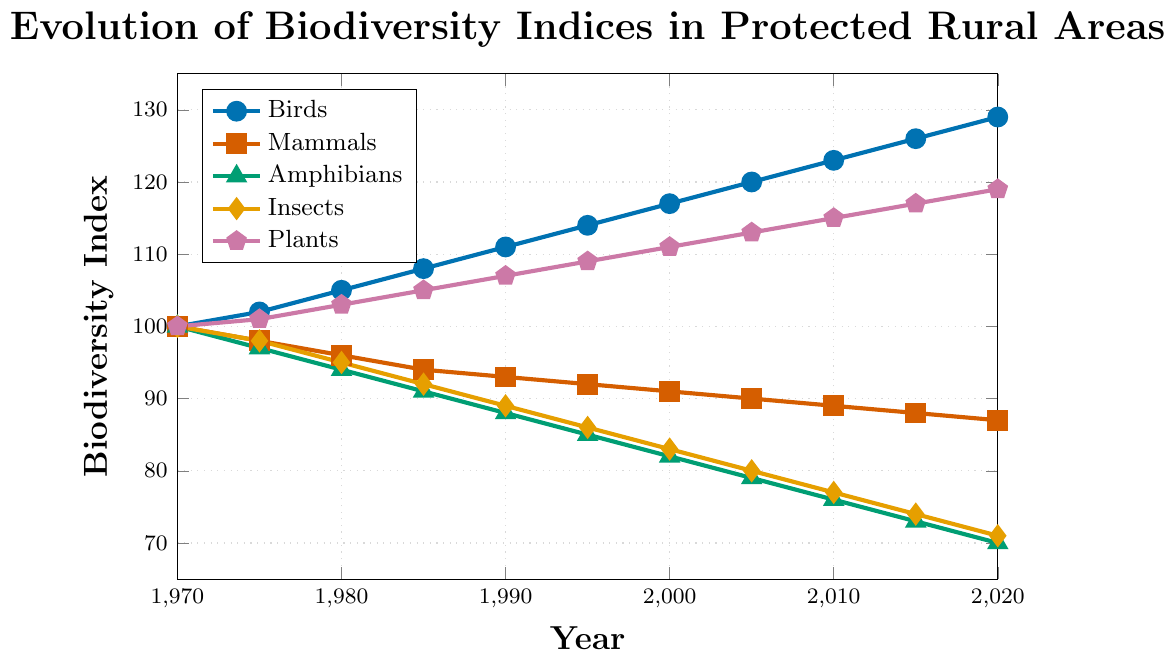What trend do we observe for the Birds biodiversity index from 1970 to 2020? Look at the line representing Birds, which is marked with circles and is blue in color. The line shows a steady increase from 100 in 1970 to 129 in 2020.
Answer: Steady increase Which species group has shown the largest decline in biodiversity index from 1970 to 2020? Compare the biodiversity indices of each species group in 1970 and 2020. The Amphibians line (green triangles) shows the largest decline, going from 100 in 1970 to 70 in 2020, resulting in a 30 point drop.
Answer: Amphibians What is the biodiversity index of Insects in 2000 and how does it compare to the Plants in the same year? Locate the points for Insects (yellow diamonds) and Plants (purple pentagons) in the year 2000. Insects have an index of 83, while Plants have an index of 111.
Answer: Insects: 83, Plants: 111 What is the average biodiversity index of Mammals over the entire period? Add up the biodiversity indices of Mammals for each year listed and divide by the number of years (11). (100+98+96+94+93+92+91+90+89+88+87) / 11 = 92.09.
Answer: 92.09 Between which two consecutive periods do Amphibians show the greatest rate of decline? Examine the year-to-year differences in the Amphibians index. The largest single drop is from 1975 to 1980, where the index went from 97 to 94, a decline of 3 points.
Answer: 1975 to 1980 How does the biodiversity index of Birds in 1990 compare with that of Insects in 1980? Check the values for Birds in 1990 and Insects in 1980. Birds have an index of 111 and Insects have an index of 95.
Answer: Birds: 111, Insects: 95 Which species group has the steadiest trend over the 50-year period? Look for the line with the most consistent slope. The Plants line (purple pentagons) has a very steady upward trend without major fluctuations.
Answer: Plants By how much has the biodiversity index for Plants increased from 1970 to 2020? Subtract the 1970 value from the 2020 value for the Plants line. 119 - 100 = 19.
Answer: 19 